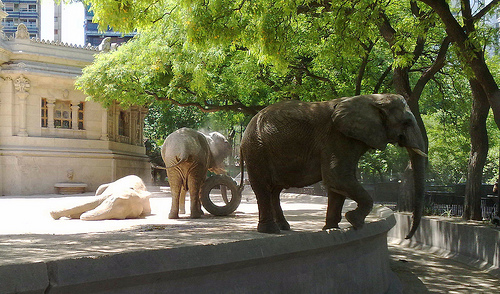How many elephants are lying down? In the image, there is a single elephant that is lying down on the ground, basking in the sun with its body fully settled on its side. 